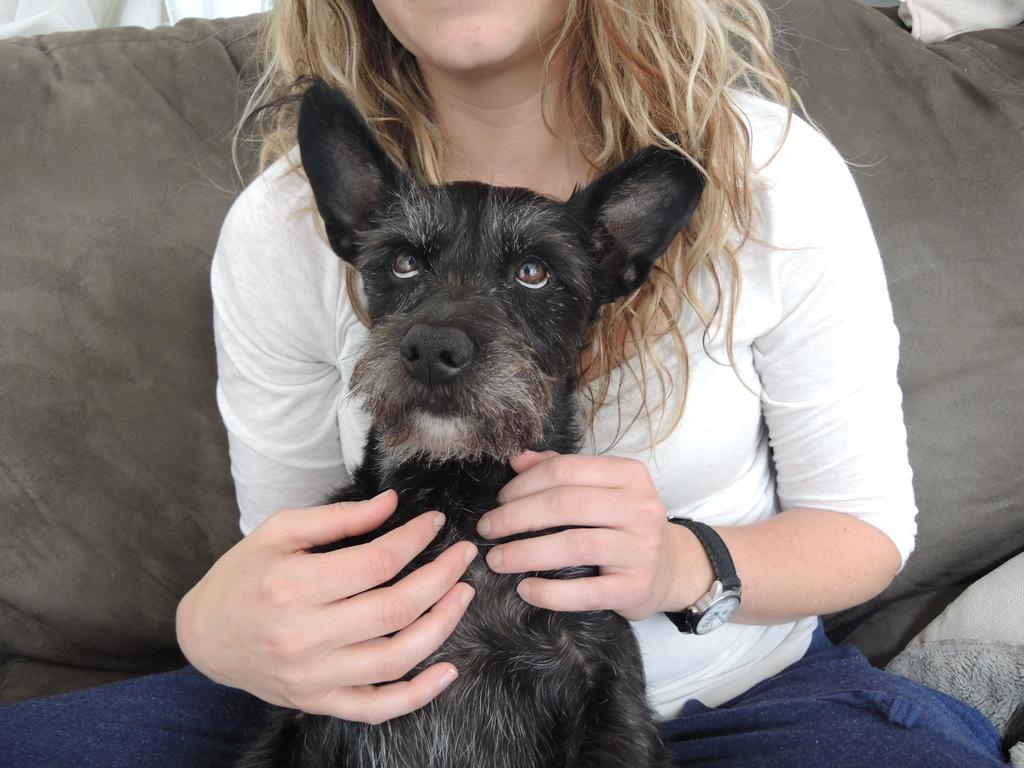Who is present in the image? There is a woman in the image. What is the woman wearing? The woman is wearing a dress and a wrist watch. What is the woman doing in the image? The woman is holding a dog with her hands and sitting on a sofa. What can be seen in the background of the image? There is a pillow and a curtain in the background of the image. What type of news can be heard coming from the radio in the image? There is no radio present in the image, so it is not possible to determine what news might be heard. 